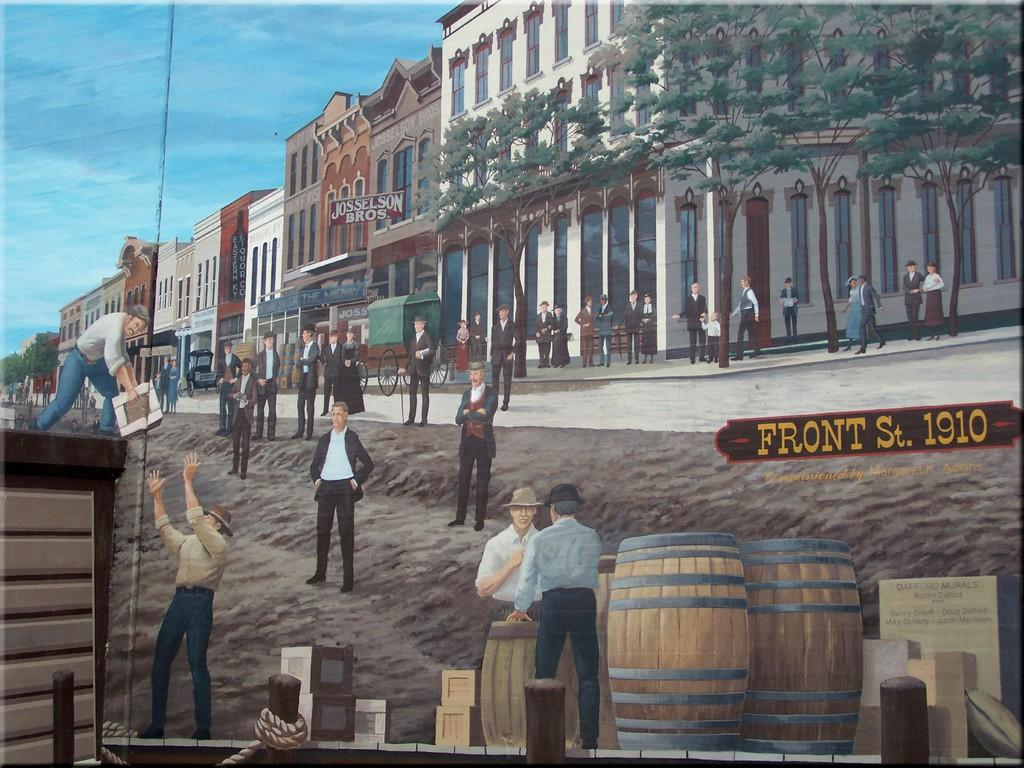<image>
Write a terse but informative summary of the picture. A painting of an old city with many people has the words Front St. 1910 on it 